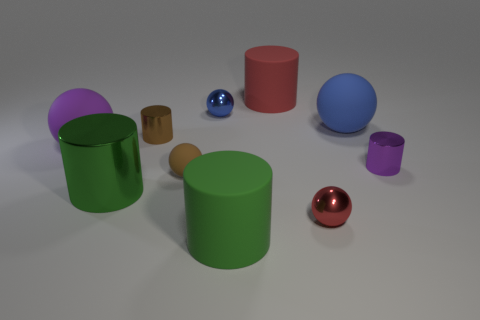Can you tell me which objects are the largest and the smallest? The largest objects appear to be the cylinders, with the green one in the front being the most prominent in size. The smallest objects are the small spheres, with the red and blue ones standing out as particularly tiny. 